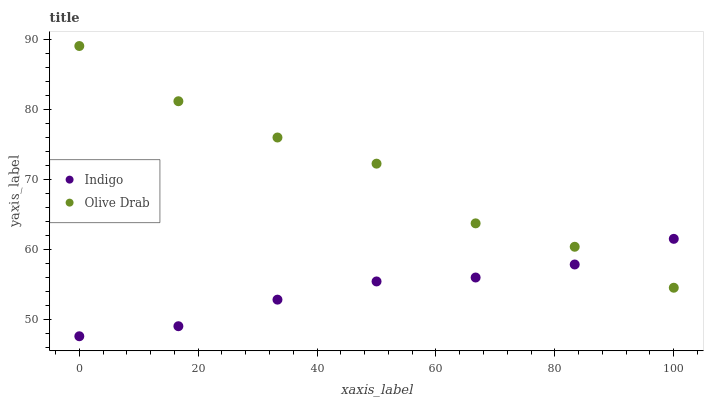Does Indigo have the minimum area under the curve?
Answer yes or no. Yes. Does Olive Drab have the maximum area under the curve?
Answer yes or no. Yes. Does Olive Drab have the minimum area under the curve?
Answer yes or no. No. Is Indigo the smoothest?
Answer yes or no. Yes. Is Olive Drab the roughest?
Answer yes or no. Yes. Is Olive Drab the smoothest?
Answer yes or no. No. Does Indigo have the lowest value?
Answer yes or no. Yes. Does Olive Drab have the lowest value?
Answer yes or no. No. Does Olive Drab have the highest value?
Answer yes or no. Yes. Does Olive Drab intersect Indigo?
Answer yes or no. Yes. Is Olive Drab less than Indigo?
Answer yes or no. No. Is Olive Drab greater than Indigo?
Answer yes or no. No. 